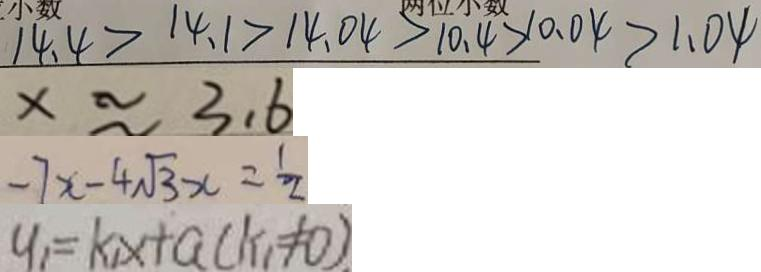<formula> <loc_0><loc_0><loc_500><loc_500>1 4 . 4 > 1 4 . 1 > 1 4 . 0 4 > 1 0 . 4 > 1 0 . 0 4 > 1 . 0 4 
 x \approx 3 . 6 
 - 7 x - 4 \sqrt { 3 } x = \frac { 1 } { 2 } 
 y _ { 1 } = k _ { 1 } x + a ( k _ { 1 } \neq 0 )</formula> 